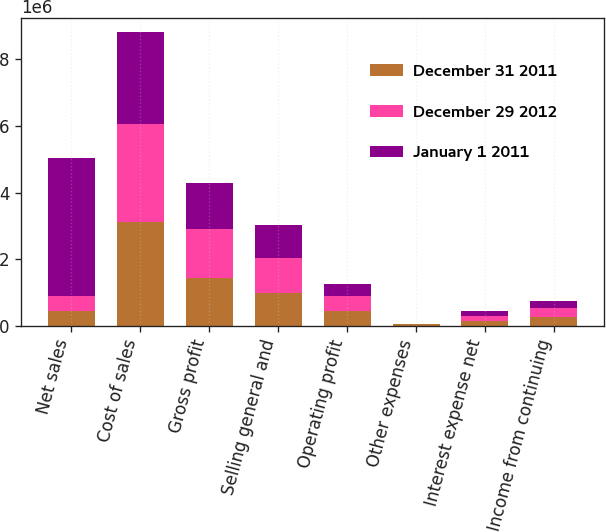Convert chart. <chart><loc_0><loc_0><loc_500><loc_500><stacked_bar_chart><ecel><fcel>Net sales<fcel>Cost of sales<fcel>Gross profit<fcel>Selling general and<fcel>Operating profit<fcel>Other expenses<fcel>Interest expense net<fcel>Income from continuing<nl><fcel>December 31 2011<fcel>443621<fcel>3.10567e+06<fcel>1.42005e+06<fcel>979932<fcel>440115<fcel>40315<fcel>136855<fcel>262945<nl><fcel>December 29 2012<fcel>443621<fcel>2.94108e+06<fcel>1.49321e+06<fcel>1.04608e+06<fcel>447127<fcel>6377<fcel>156198<fcel>284552<nl><fcel>January 1 2011<fcel>4.14601e+06<fcel>2.77017e+06<fcel>1.37584e+06<fcel>994973<fcel>380865<fcel>20221<fcel>150143<fcel>210501<nl></chart> 